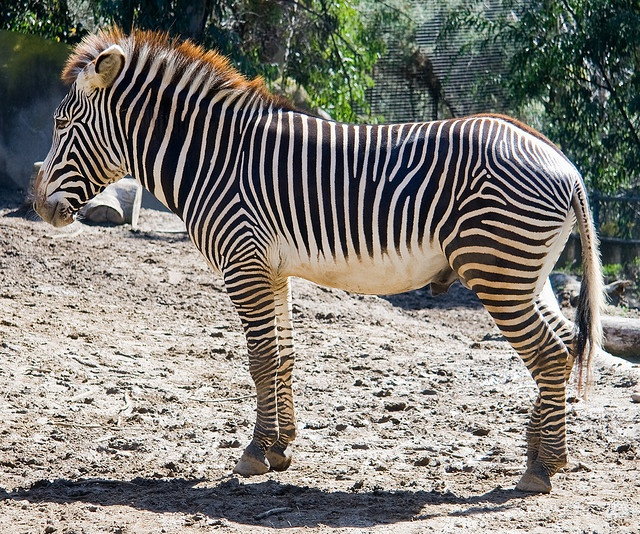Describe the objects in this image and their specific colors. I can see a zebra in black, darkgray, tan, and lightgray tones in this image. 